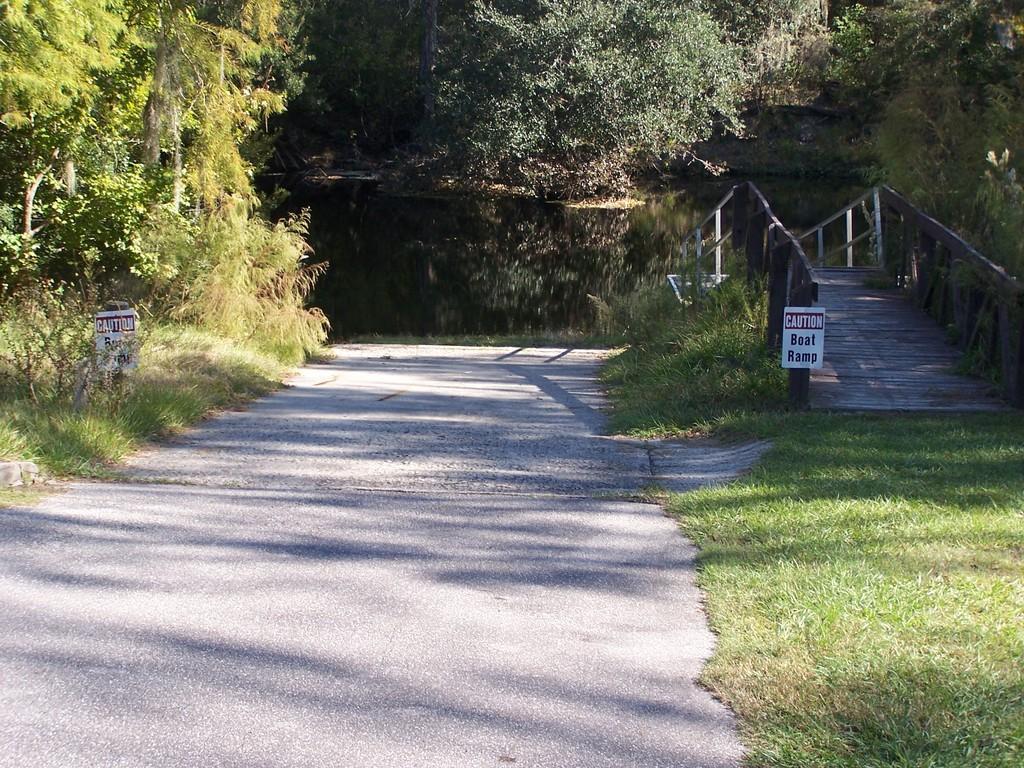Please provide a concise description of this image. This is the road. I can see the caution boards. This is the grass. I think this looks like a small pond with the water. These are the trees with branches and leaves. This looks like a wooden bridge. 